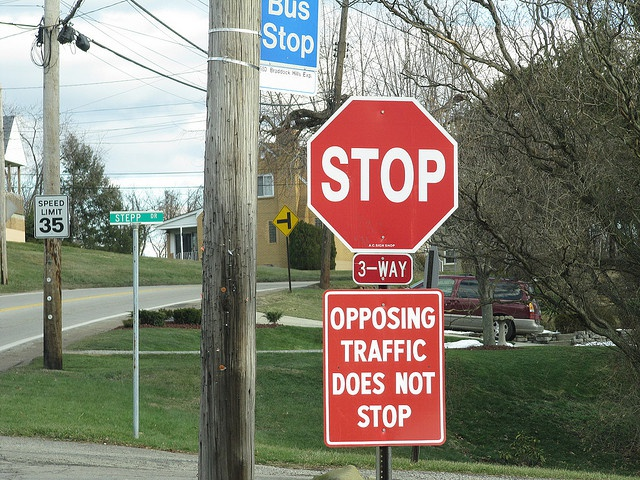Describe the objects in this image and their specific colors. I can see stop sign in white and brown tones and car in white, gray, black, maroon, and darkgray tones in this image. 